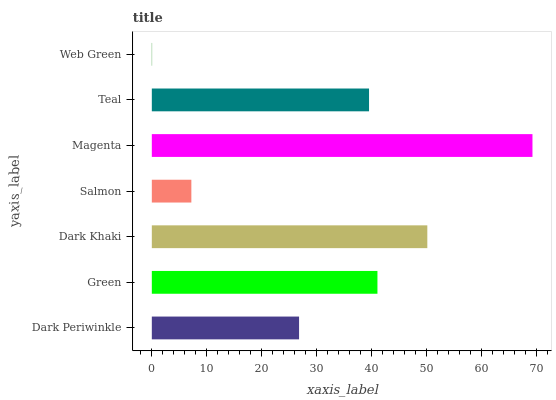Is Web Green the minimum?
Answer yes or no. Yes. Is Magenta the maximum?
Answer yes or no. Yes. Is Green the minimum?
Answer yes or no. No. Is Green the maximum?
Answer yes or no. No. Is Green greater than Dark Periwinkle?
Answer yes or no. Yes. Is Dark Periwinkle less than Green?
Answer yes or no. Yes. Is Dark Periwinkle greater than Green?
Answer yes or no. No. Is Green less than Dark Periwinkle?
Answer yes or no. No. Is Teal the high median?
Answer yes or no. Yes. Is Teal the low median?
Answer yes or no. Yes. Is Salmon the high median?
Answer yes or no. No. Is Magenta the low median?
Answer yes or no. No. 